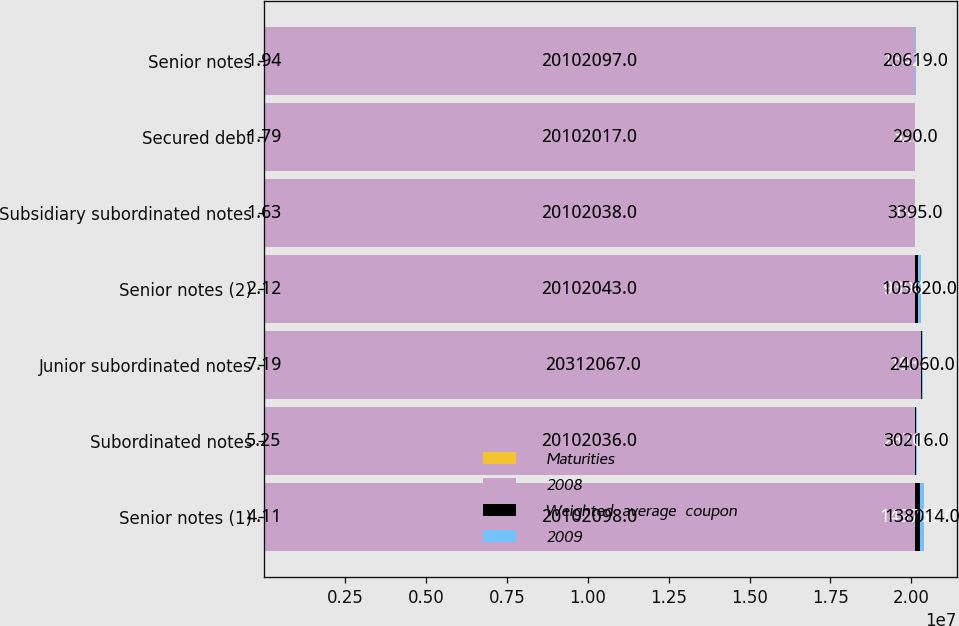Convert chart to OTSL. <chart><loc_0><loc_0><loc_500><loc_500><stacked_bar_chart><ecel><fcel>Senior notes (1)<fcel>Subordinated notes<fcel>Junior subordinated notes<fcel>Senior notes (2)<fcel>Subsidiary subordinated notes<fcel>Secured debt<fcel>Senior notes<nl><fcel>Maturities<fcel>4.11<fcel>5.25<fcel>7.19<fcel>2.12<fcel>1.63<fcel>1.79<fcel>1.94<nl><fcel>2008<fcel>2.01021e+07<fcel>2.0102e+07<fcel>2.03121e+07<fcel>2.0102e+07<fcel>2.0102e+07<fcel>2.0102e+07<fcel>2.01021e+07<nl><fcel>Weighted  average  coupon<fcel>149751<fcel>28708<fcel>19345<fcel>93909<fcel>3060<fcel>325<fcel>13422<nl><fcel>2009<fcel>138014<fcel>30216<fcel>24060<fcel>105620<fcel>3395<fcel>290<fcel>20619<nl></chart> 